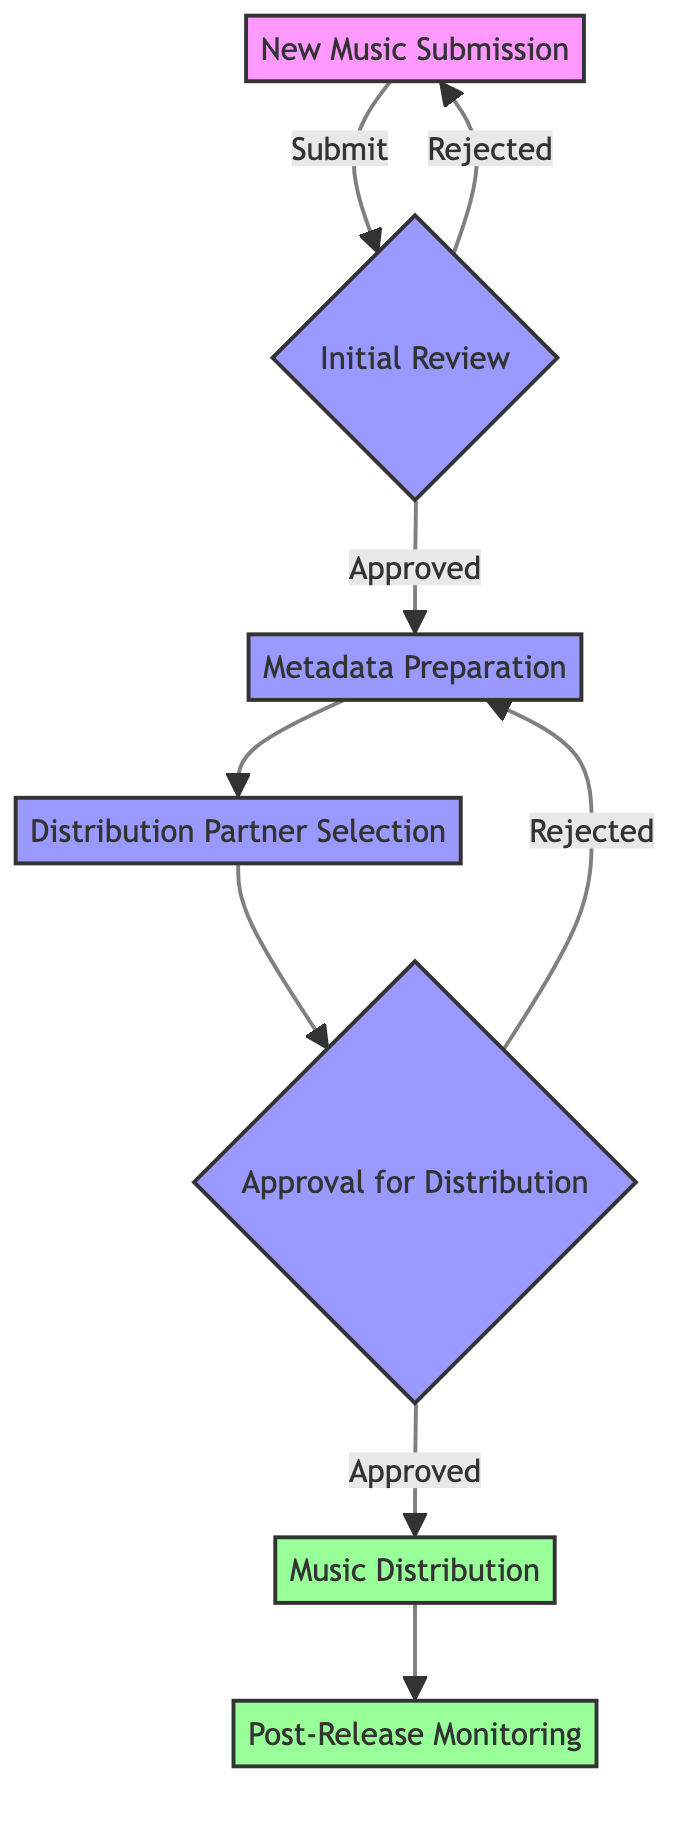What is the first step in the music distribution process? The first node in the flowchart is "New Music Submission," which indicates that the process starts when an artist submits new music for distribution.
Answer: New Music Submission How many main steps are there in the music distribution flowchart? There are a total of 7 main steps represented in the flowchart, from "New Music Submission" to "Post-Release Monitoring."
Answer: 7 What happens if the initial review is rejected? According to the diagram, if the initial review is rejected, the process loops back to "New Music Submission," indicating that the artist must submit the music again.
Answer: New Music Submission Which step follows the metadata preparation? After "Metadata Preparation," the next step in the flowchart is "Distribution Partner Selection," showing the sequence of actions in the process.
Answer: Distribution Partner Selection What is the outcome if the approval for distribution is granted? If the approval for distribution is granted, the next step is "Music Distribution," indicating that the music will then be distributed to platforms.
Answer: Music Distribution Which two steps are marked as approved in the flowchart? The two steps marked as approved in the flowchart are "Music Distribution" and "Post-Release Monitoring," indicating successful completion of the distribution phase.
Answer: Music Distribution, Post-Release Monitoring What is required before moving to the music distribution phase? Before moving to "Music Distribution," the diagram indicates that "Approval for Distribution" must be granted, showing it as a prerequisite step.
Answer: Approval for Distribution What type of feedback is gathered in the last step? In the final step, "Post-Release Monitoring," the feedback collected is listener feedback, indicating that the performance of the released music is observed.
Answer: Listener feedback What step follows after selecting distribution partners? After "Distribution Partner Selection," the next step is "Approval for Distribution," demonstrating the flow from choosing partners to seeking final approval.
Answer: Approval for Distribution 